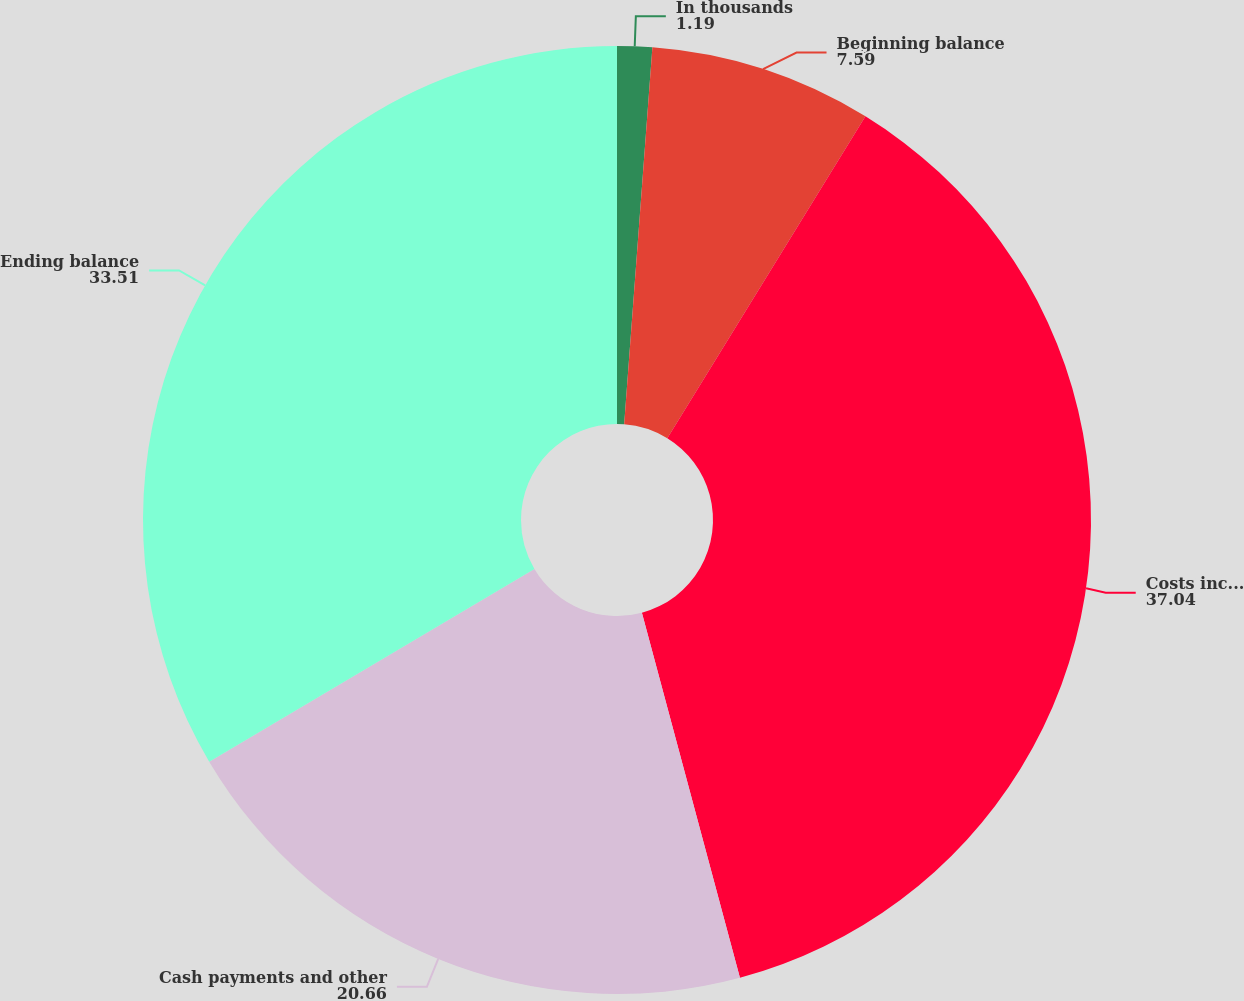<chart> <loc_0><loc_0><loc_500><loc_500><pie_chart><fcel>In thousands<fcel>Beginning balance<fcel>Costs incurred<fcel>Cash payments and other<fcel>Ending balance<nl><fcel>1.19%<fcel>7.59%<fcel>37.04%<fcel>20.66%<fcel>33.51%<nl></chart> 